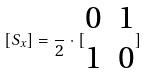Convert formula to latex. <formula><loc_0><loc_0><loc_500><loc_500>[ S _ { x } ] = \frac { } { 2 } \cdot [ \begin{matrix} 0 & 1 \\ 1 & 0 \end{matrix} ]</formula> 